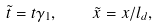<formula> <loc_0><loc_0><loc_500><loc_500>\tilde { t } = t \gamma _ { 1 } , \quad \tilde { x } = x / l _ { d } ,</formula> 